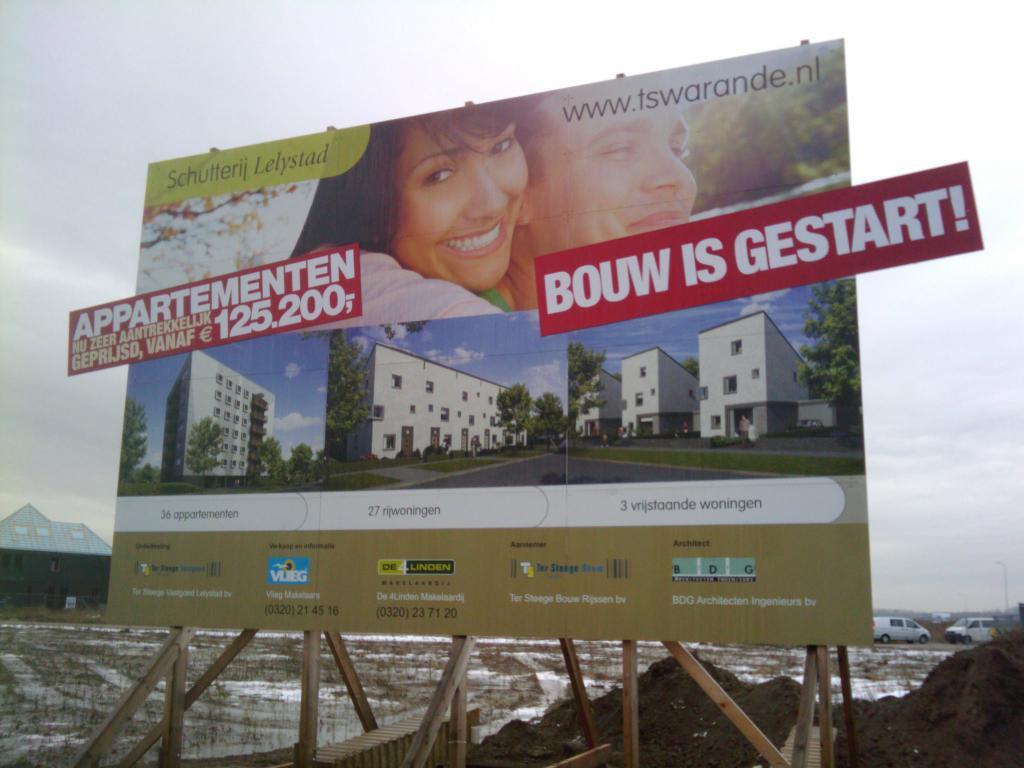Please provide a concise description of this image. In the foreground of this image, there is a hoarding on which written as" Appartmenten" and few text written more. In the background, we can see building, vehicles, sand, and the cloud. 